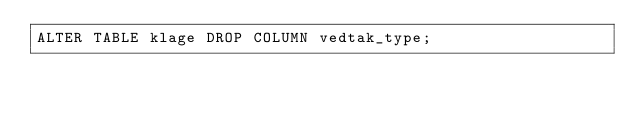<code> <loc_0><loc_0><loc_500><loc_500><_SQL_>ALTER TABLE klage DROP COLUMN vedtak_type;
</code> 